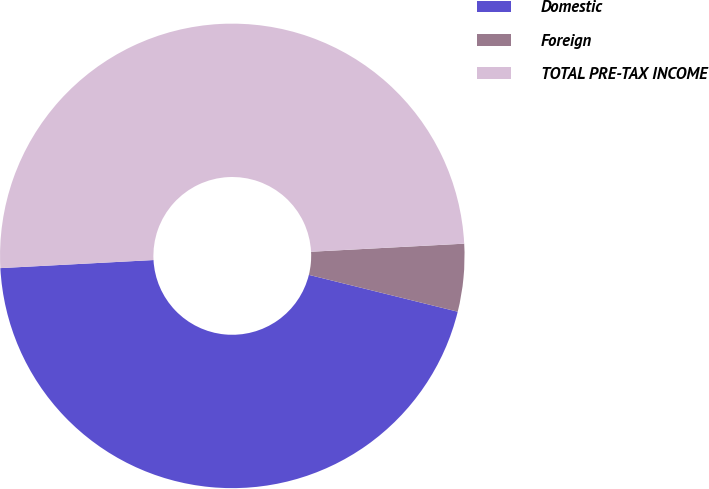<chart> <loc_0><loc_0><loc_500><loc_500><pie_chart><fcel>Domestic<fcel>Foreign<fcel>TOTAL PRE-TAX INCOME<nl><fcel>45.3%<fcel>4.7%<fcel>50.0%<nl></chart> 